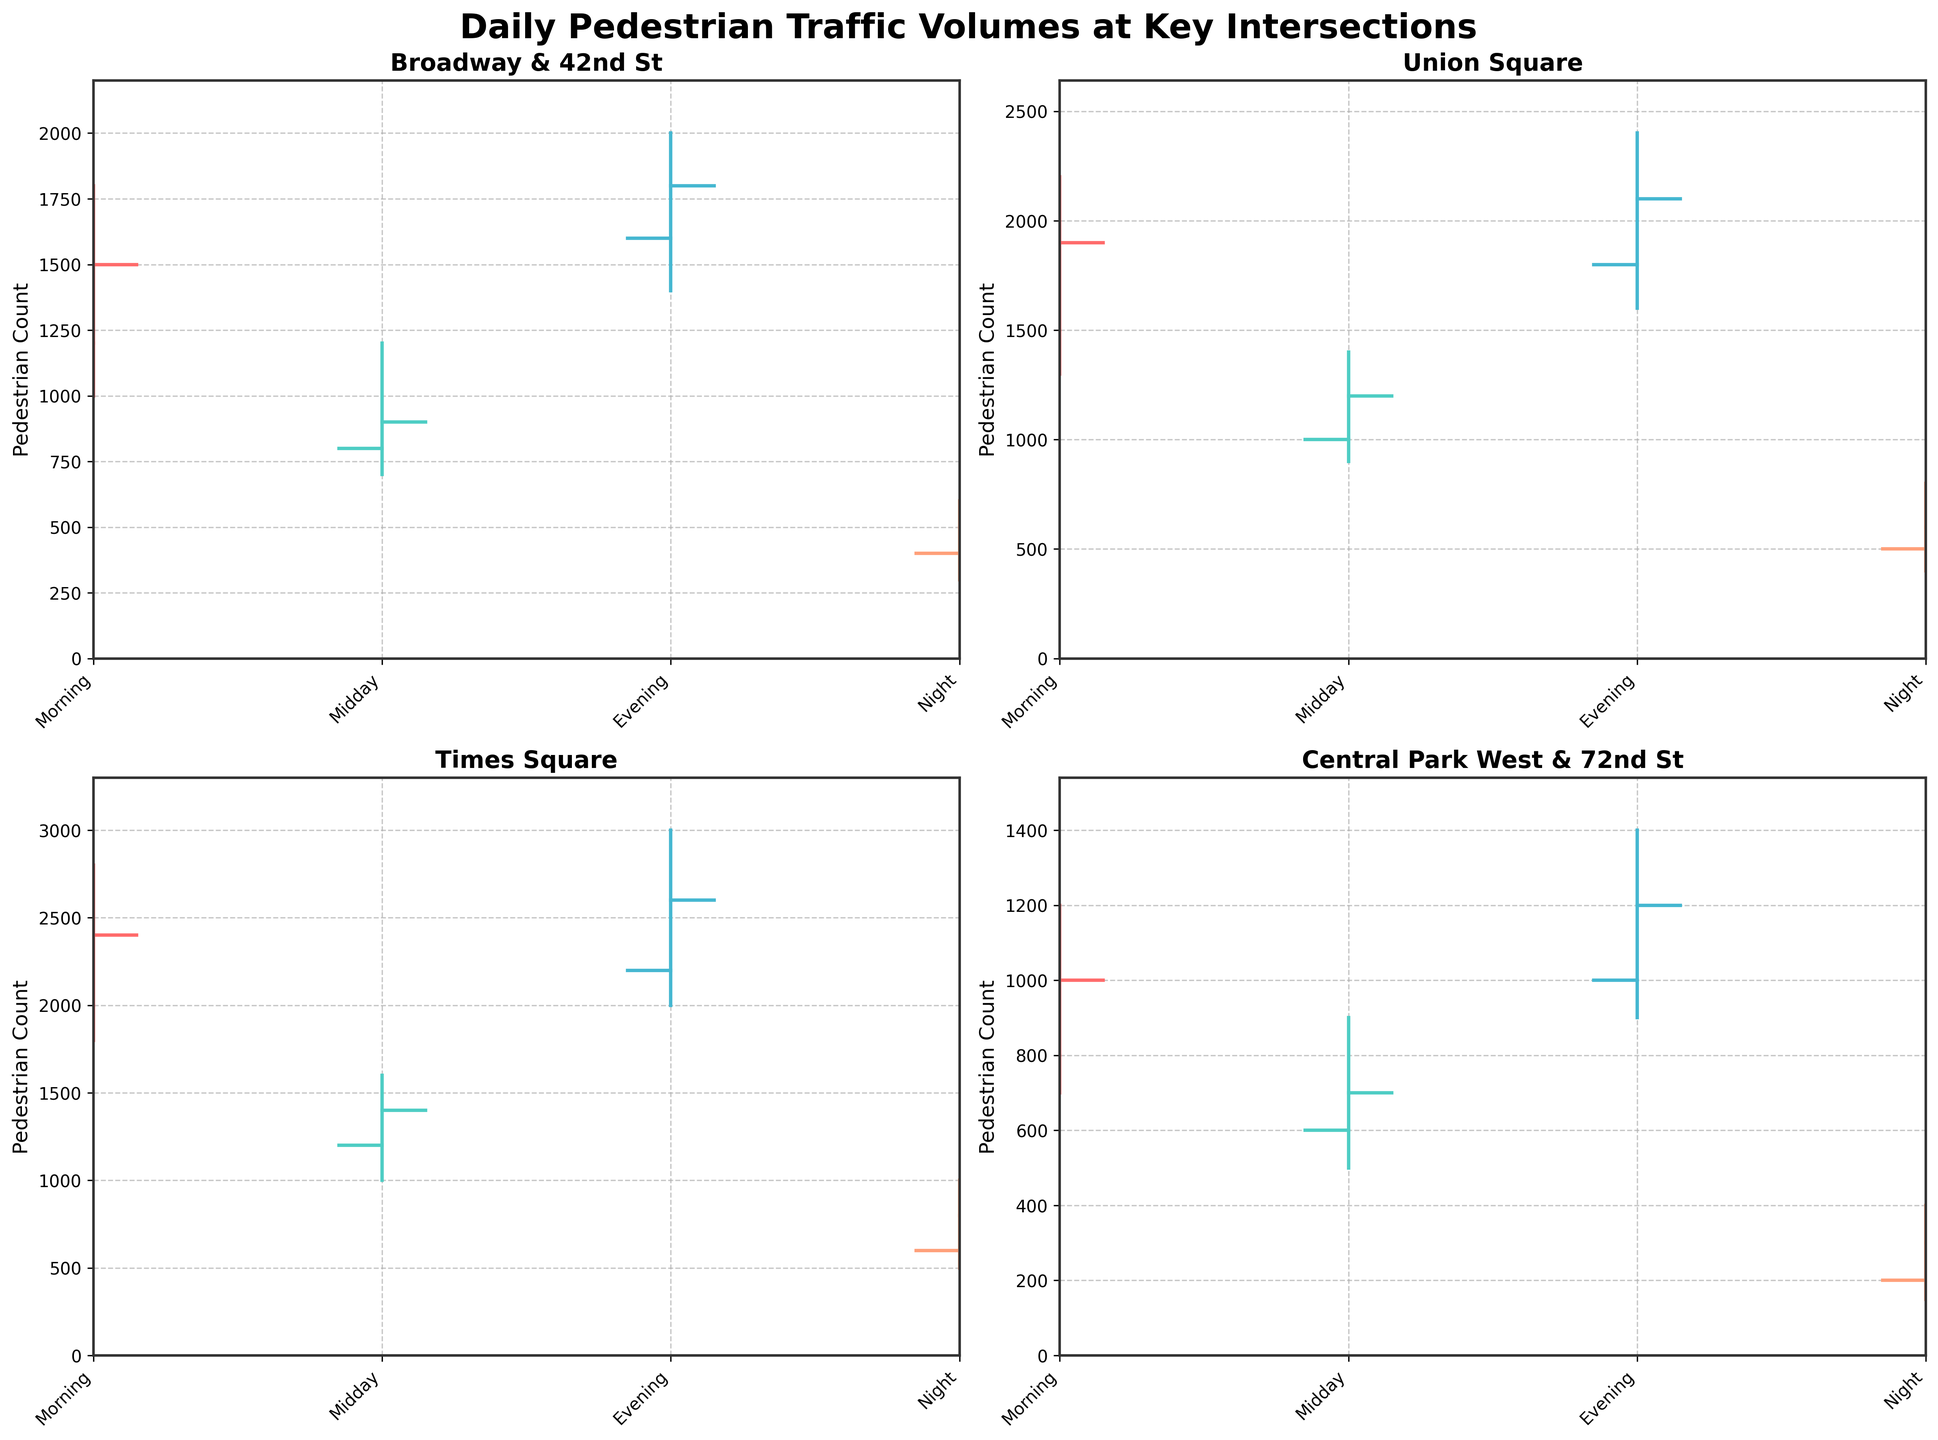What is the title of the figure? The title of the figure appears at the top of the chart, usually in a larger and bold font for easy identification. It summarizes what the figure is about.
Answer: Daily Pedestrian Traffic Volumes at Key Intersections Which intersection has the highest pedestrian count in the evening? Check the Evening peak data for all intersections and compare their high values. The intersection with the highest value is the one with the highest pedestrian count in the evening.
Answer: Times Square How do the morning and night pedestrian volumes at Central Park West & 72nd St compare? Refer to the morning and night data for Central Park West & 72nd St. Compare the high values of both times to determine how they match up.
Answer: Morning is higher What is the lowest pedestrian count recorded at Times Square? Investigate the low values for Times Square across all time periods (Morning, Midday, Evening, Night) and identify the minimum value among them.
Answer: 500 Which intersection has the most significant drop from morning to midday? Calculate the drop for each intersection by subtracting the midday close value from the morning close value, and identify which intersection has the largest result.
Answer: Broadway & 42nd St At which intersection are night peaks more than half of evening peaks? For each intersection, calculate half of the evening peak (high value) and then compare it with the night peak. Determine which intersections meet the criterion.
Answer: Union Square, Times Square Which time period often shows the highest pedestrian count across all intersections? Review the high values across each time period for all the intersections and find which time period appears most frequently as the maximum.
Answer: Evening Compare the overall trend for Union Square and Central Park West & 72nd St. Are their volumes correlated at any time? Analyze the patterns of Open, High, Low, and Close values for Union Square and Central Park West & 72nd St. across all periods. Look for similar trends or points of correlation between the data points.
Answer: No direct correlation Identify the intersection and time period with the smallest range (difference between high and low values) Calculate the range (high - low) for each intersection and time period combination and identify which combination has the smallest value.
Answer: Central Park West & 72nd St, Night (250) 